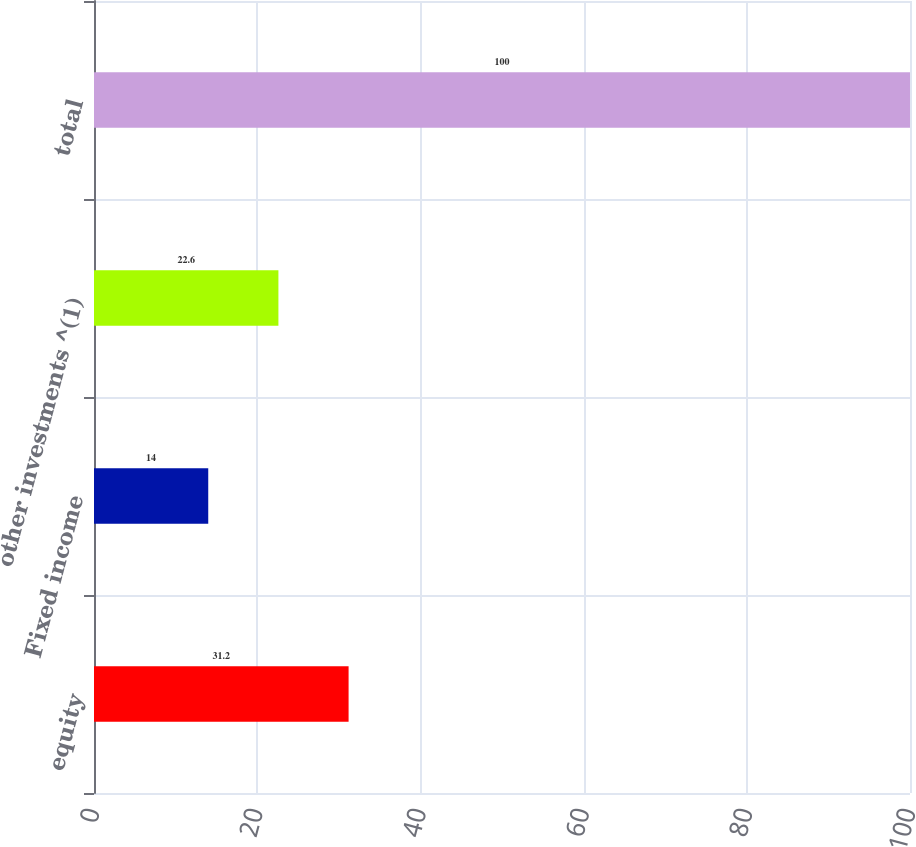<chart> <loc_0><loc_0><loc_500><loc_500><bar_chart><fcel>equity<fcel>Fixed income<fcel>other investments ^(1)<fcel>total<nl><fcel>31.2<fcel>14<fcel>22.6<fcel>100<nl></chart> 